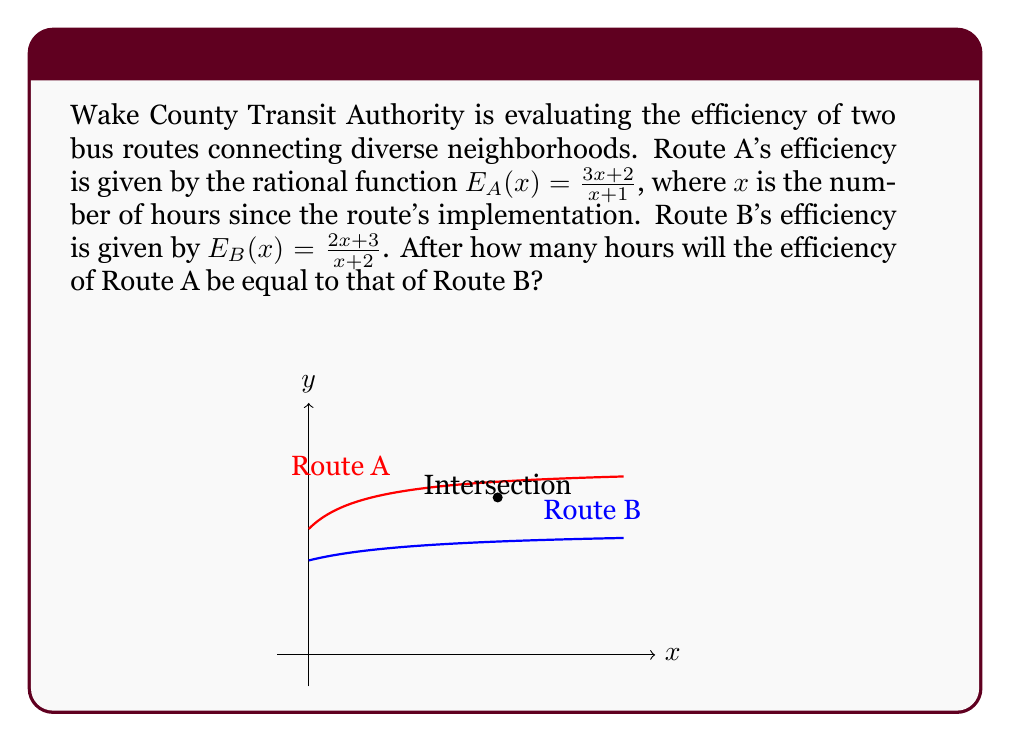Can you answer this question? To find when the efficiency of both routes will be equal, we need to set the two rational functions equal to each other and solve for x:

1) Set the equations equal:
   $$\frac{3x+2}{x+1} = \frac{2x+3}{x+2}$$

2) Cross-multiply to eliminate denominators:
   $$(3x+2)(x+2) = (2x+3)(x+1)$$

3) Expand the brackets:
   $$3x^2 + 6x + 2x + 4 = 2x^2 + 2x + 3x + 3$$
   $$3x^2 + 8x + 4 = 2x^2 + 5x + 3$$

4) Subtract the right side from both sides:
   $$x^2 + 3x + 1 = 0$$

5) This is a quadratic equation. We can solve it using the quadratic formula:
   $$x = \frac{-b \pm \sqrt{b^2 - 4ac}}{2a}$$
   where $a=1$, $b=3$, and $c=1$

6) Substituting these values:
   $$x = \frac{-3 \pm \sqrt{3^2 - 4(1)(1)}}{2(1)} = \frac{-3 \pm \sqrt{5}}{2}$$

7) This gives us two solutions:
   $$x_1 = \frac{-3 + \sqrt{5}}{2} \approx -0.38$$
   $$x_2 = \frac{-3 - \sqrt{5}}{2} \approx -2.62$$

8) Since time cannot be negative, we discard the negative solutions. There are no positive real solutions.
Answer: The efficiencies will never be equal for positive time values. 